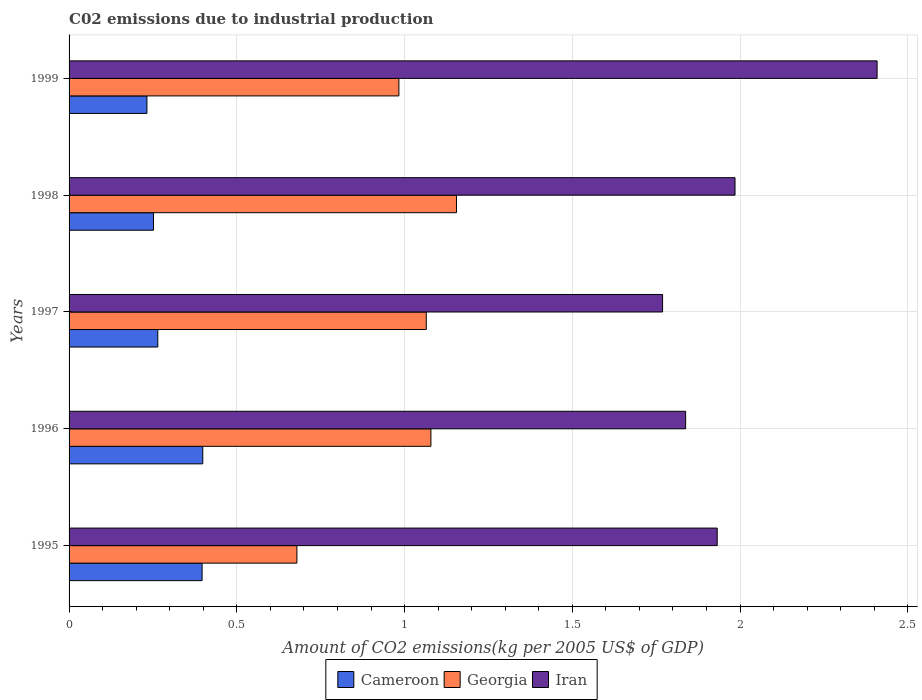How many different coloured bars are there?
Keep it short and to the point. 3. How many groups of bars are there?
Ensure brevity in your answer.  5. In how many cases, is the number of bars for a given year not equal to the number of legend labels?
Your answer should be compact. 0. What is the amount of CO2 emitted due to industrial production in Georgia in 1999?
Your answer should be very brief. 0.98. Across all years, what is the maximum amount of CO2 emitted due to industrial production in Iran?
Give a very brief answer. 2.41. Across all years, what is the minimum amount of CO2 emitted due to industrial production in Georgia?
Provide a short and direct response. 0.68. What is the total amount of CO2 emitted due to industrial production in Iran in the graph?
Your answer should be compact. 9.93. What is the difference between the amount of CO2 emitted due to industrial production in Iran in 1995 and that in 1999?
Give a very brief answer. -0.48. What is the difference between the amount of CO2 emitted due to industrial production in Cameroon in 1995 and the amount of CO2 emitted due to industrial production in Georgia in 1999?
Provide a succinct answer. -0.59. What is the average amount of CO2 emitted due to industrial production in Cameroon per year?
Your answer should be very brief. 0.31. In the year 1995, what is the difference between the amount of CO2 emitted due to industrial production in Georgia and amount of CO2 emitted due to industrial production in Iran?
Keep it short and to the point. -1.25. In how many years, is the amount of CO2 emitted due to industrial production in Georgia greater than 0.9 kg?
Keep it short and to the point. 4. What is the ratio of the amount of CO2 emitted due to industrial production in Cameroon in 1996 to that in 1999?
Provide a succinct answer. 1.72. Is the amount of CO2 emitted due to industrial production in Georgia in 1995 less than that in 1996?
Keep it short and to the point. Yes. Is the difference between the amount of CO2 emitted due to industrial production in Georgia in 1995 and 1997 greater than the difference between the amount of CO2 emitted due to industrial production in Iran in 1995 and 1997?
Your response must be concise. No. What is the difference between the highest and the second highest amount of CO2 emitted due to industrial production in Cameroon?
Provide a succinct answer. 0. What is the difference between the highest and the lowest amount of CO2 emitted due to industrial production in Iran?
Offer a very short reply. 0.64. What does the 3rd bar from the top in 1998 represents?
Provide a succinct answer. Cameroon. What does the 1st bar from the bottom in 1995 represents?
Your response must be concise. Cameroon. Is it the case that in every year, the sum of the amount of CO2 emitted due to industrial production in Georgia and amount of CO2 emitted due to industrial production in Cameroon is greater than the amount of CO2 emitted due to industrial production in Iran?
Keep it short and to the point. No. How many bars are there?
Your response must be concise. 15. How many years are there in the graph?
Provide a succinct answer. 5. Are the values on the major ticks of X-axis written in scientific E-notation?
Provide a short and direct response. No. Does the graph contain any zero values?
Make the answer very short. No. Does the graph contain grids?
Your response must be concise. Yes. Where does the legend appear in the graph?
Your answer should be very brief. Bottom center. How many legend labels are there?
Your answer should be compact. 3. What is the title of the graph?
Offer a terse response. C02 emissions due to industrial production. What is the label or title of the X-axis?
Provide a succinct answer. Amount of CO2 emissions(kg per 2005 US$ of GDP). What is the Amount of CO2 emissions(kg per 2005 US$ of GDP) of Cameroon in 1995?
Your answer should be very brief. 0.4. What is the Amount of CO2 emissions(kg per 2005 US$ of GDP) in Georgia in 1995?
Your answer should be compact. 0.68. What is the Amount of CO2 emissions(kg per 2005 US$ of GDP) in Iran in 1995?
Keep it short and to the point. 1.93. What is the Amount of CO2 emissions(kg per 2005 US$ of GDP) in Cameroon in 1996?
Ensure brevity in your answer.  0.4. What is the Amount of CO2 emissions(kg per 2005 US$ of GDP) of Georgia in 1996?
Your answer should be very brief. 1.08. What is the Amount of CO2 emissions(kg per 2005 US$ of GDP) in Iran in 1996?
Provide a short and direct response. 1.84. What is the Amount of CO2 emissions(kg per 2005 US$ of GDP) in Cameroon in 1997?
Provide a short and direct response. 0.26. What is the Amount of CO2 emissions(kg per 2005 US$ of GDP) of Georgia in 1997?
Give a very brief answer. 1.06. What is the Amount of CO2 emissions(kg per 2005 US$ of GDP) of Iran in 1997?
Provide a short and direct response. 1.77. What is the Amount of CO2 emissions(kg per 2005 US$ of GDP) in Cameroon in 1998?
Make the answer very short. 0.25. What is the Amount of CO2 emissions(kg per 2005 US$ of GDP) of Georgia in 1998?
Make the answer very short. 1.15. What is the Amount of CO2 emissions(kg per 2005 US$ of GDP) in Iran in 1998?
Give a very brief answer. 1.99. What is the Amount of CO2 emissions(kg per 2005 US$ of GDP) of Cameroon in 1999?
Offer a very short reply. 0.23. What is the Amount of CO2 emissions(kg per 2005 US$ of GDP) in Georgia in 1999?
Give a very brief answer. 0.98. What is the Amount of CO2 emissions(kg per 2005 US$ of GDP) of Iran in 1999?
Offer a terse response. 2.41. Across all years, what is the maximum Amount of CO2 emissions(kg per 2005 US$ of GDP) of Cameroon?
Ensure brevity in your answer.  0.4. Across all years, what is the maximum Amount of CO2 emissions(kg per 2005 US$ of GDP) in Georgia?
Your response must be concise. 1.15. Across all years, what is the maximum Amount of CO2 emissions(kg per 2005 US$ of GDP) in Iran?
Provide a short and direct response. 2.41. Across all years, what is the minimum Amount of CO2 emissions(kg per 2005 US$ of GDP) of Cameroon?
Your answer should be very brief. 0.23. Across all years, what is the minimum Amount of CO2 emissions(kg per 2005 US$ of GDP) of Georgia?
Provide a short and direct response. 0.68. Across all years, what is the minimum Amount of CO2 emissions(kg per 2005 US$ of GDP) of Iran?
Keep it short and to the point. 1.77. What is the total Amount of CO2 emissions(kg per 2005 US$ of GDP) of Cameroon in the graph?
Your answer should be very brief. 1.54. What is the total Amount of CO2 emissions(kg per 2005 US$ of GDP) of Georgia in the graph?
Your answer should be compact. 4.96. What is the total Amount of CO2 emissions(kg per 2005 US$ of GDP) of Iran in the graph?
Your response must be concise. 9.93. What is the difference between the Amount of CO2 emissions(kg per 2005 US$ of GDP) in Cameroon in 1995 and that in 1996?
Your response must be concise. -0. What is the difference between the Amount of CO2 emissions(kg per 2005 US$ of GDP) of Georgia in 1995 and that in 1996?
Your answer should be very brief. -0.4. What is the difference between the Amount of CO2 emissions(kg per 2005 US$ of GDP) in Iran in 1995 and that in 1996?
Ensure brevity in your answer.  0.09. What is the difference between the Amount of CO2 emissions(kg per 2005 US$ of GDP) in Cameroon in 1995 and that in 1997?
Make the answer very short. 0.13. What is the difference between the Amount of CO2 emissions(kg per 2005 US$ of GDP) in Georgia in 1995 and that in 1997?
Your answer should be compact. -0.39. What is the difference between the Amount of CO2 emissions(kg per 2005 US$ of GDP) in Iran in 1995 and that in 1997?
Offer a terse response. 0.16. What is the difference between the Amount of CO2 emissions(kg per 2005 US$ of GDP) in Cameroon in 1995 and that in 1998?
Provide a short and direct response. 0.14. What is the difference between the Amount of CO2 emissions(kg per 2005 US$ of GDP) in Georgia in 1995 and that in 1998?
Make the answer very short. -0.48. What is the difference between the Amount of CO2 emissions(kg per 2005 US$ of GDP) in Iran in 1995 and that in 1998?
Provide a short and direct response. -0.05. What is the difference between the Amount of CO2 emissions(kg per 2005 US$ of GDP) in Cameroon in 1995 and that in 1999?
Your answer should be compact. 0.16. What is the difference between the Amount of CO2 emissions(kg per 2005 US$ of GDP) in Georgia in 1995 and that in 1999?
Offer a terse response. -0.3. What is the difference between the Amount of CO2 emissions(kg per 2005 US$ of GDP) of Iran in 1995 and that in 1999?
Provide a succinct answer. -0.48. What is the difference between the Amount of CO2 emissions(kg per 2005 US$ of GDP) of Cameroon in 1996 and that in 1997?
Ensure brevity in your answer.  0.13. What is the difference between the Amount of CO2 emissions(kg per 2005 US$ of GDP) in Georgia in 1996 and that in 1997?
Your answer should be compact. 0.01. What is the difference between the Amount of CO2 emissions(kg per 2005 US$ of GDP) in Iran in 1996 and that in 1997?
Ensure brevity in your answer.  0.07. What is the difference between the Amount of CO2 emissions(kg per 2005 US$ of GDP) in Cameroon in 1996 and that in 1998?
Offer a very short reply. 0.15. What is the difference between the Amount of CO2 emissions(kg per 2005 US$ of GDP) of Georgia in 1996 and that in 1998?
Provide a succinct answer. -0.08. What is the difference between the Amount of CO2 emissions(kg per 2005 US$ of GDP) of Iran in 1996 and that in 1998?
Your answer should be compact. -0.15. What is the difference between the Amount of CO2 emissions(kg per 2005 US$ of GDP) of Cameroon in 1996 and that in 1999?
Your response must be concise. 0.17. What is the difference between the Amount of CO2 emissions(kg per 2005 US$ of GDP) of Georgia in 1996 and that in 1999?
Your answer should be compact. 0.1. What is the difference between the Amount of CO2 emissions(kg per 2005 US$ of GDP) of Iran in 1996 and that in 1999?
Your answer should be compact. -0.57. What is the difference between the Amount of CO2 emissions(kg per 2005 US$ of GDP) of Cameroon in 1997 and that in 1998?
Provide a short and direct response. 0.01. What is the difference between the Amount of CO2 emissions(kg per 2005 US$ of GDP) in Georgia in 1997 and that in 1998?
Keep it short and to the point. -0.09. What is the difference between the Amount of CO2 emissions(kg per 2005 US$ of GDP) of Iran in 1997 and that in 1998?
Keep it short and to the point. -0.22. What is the difference between the Amount of CO2 emissions(kg per 2005 US$ of GDP) in Cameroon in 1997 and that in 1999?
Offer a very short reply. 0.03. What is the difference between the Amount of CO2 emissions(kg per 2005 US$ of GDP) in Georgia in 1997 and that in 1999?
Give a very brief answer. 0.08. What is the difference between the Amount of CO2 emissions(kg per 2005 US$ of GDP) of Iran in 1997 and that in 1999?
Keep it short and to the point. -0.64. What is the difference between the Amount of CO2 emissions(kg per 2005 US$ of GDP) in Cameroon in 1998 and that in 1999?
Your response must be concise. 0.02. What is the difference between the Amount of CO2 emissions(kg per 2005 US$ of GDP) of Georgia in 1998 and that in 1999?
Your answer should be very brief. 0.17. What is the difference between the Amount of CO2 emissions(kg per 2005 US$ of GDP) of Iran in 1998 and that in 1999?
Your answer should be very brief. -0.42. What is the difference between the Amount of CO2 emissions(kg per 2005 US$ of GDP) of Cameroon in 1995 and the Amount of CO2 emissions(kg per 2005 US$ of GDP) of Georgia in 1996?
Offer a terse response. -0.68. What is the difference between the Amount of CO2 emissions(kg per 2005 US$ of GDP) of Cameroon in 1995 and the Amount of CO2 emissions(kg per 2005 US$ of GDP) of Iran in 1996?
Provide a succinct answer. -1.44. What is the difference between the Amount of CO2 emissions(kg per 2005 US$ of GDP) of Georgia in 1995 and the Amount of CO2 emissions(kg per 2005 US$ of GDP) of Iran in 1996?
Provide a short and direct response. -1.16. What is the difference between the Amount of CO2 emissions(kg per 2005 US$ of GDP) in Cameroon in 1995 and the Amount of CO2 emissions(kg per 2005 US$ of GDP) in Georgia in 1997?
Provide a succinct answer. -0.67. What is the difference between the Amount of CO2 emissions(kg per 2005 US$ of GDP) in Cameroon in 1995 and the Amount of CO2 emissions(kg per 2005 US$ of GDP) in Iran in 1997?
Ensure brevity in your answer.  -1.37. What is the difference between the Amount of CO2 emissions(kg per 2005 US$ of GDP) of Georgia in 1995 and the Amount of CO2 emissions(kg per 2005 US$ of GDP) of Iran in 1997?
Provide a succinct answer. -1.09. What is the difference between the Amount of CO2 emissions(kg per 2005 US$ of GDP) of Cameroon in 1995 and the Amount of CO2 emissions(kg per 2005 US$ of GDP) of Georgia in 1998?
Provide a short and direct response. -0.76. What is the difference between the Amount of CO2 emissions(kg per 2005 US$ of GDP) of Cameroon in 1995 and the Amount of CO2 emissions(kg per 2005 US$ of GDP) of Iran in 1998?
Keep it short and to the point. -1.59. What is the difference between the Amount of CO2 emissions(kg per 2005 US$ of GDP) in Georgia in 1995 and the Amount of CO2 emissions(kg per 2005 US$ of GDP) in Iran in 1998?
Your response must be concise. -1.31. What is the difference between the Amount of CO2 emissions(kg per 2005 US$ of GDP) in Cameroon in 1995 and the Amount of CO2 emissions(kg per 2005 US$ of GDP) in Georgia in 1999?
Give a very brief answer. -0.59. What is the difference between the Amount of CO2 emissions(kg per 2005 US$ of GDP) in Cameroon in 1995 and the Amount of CO2 emissions(kg per 2005 US$ of GDP) in Iran in 1999?
Your answer should be compact. -2.01. What is the difference between the Amount of CO2 emissions(kg per 2005 US$ of GDP) in Georgia in 1995 and the Amount of CO2 emissions(kg per 2005 US$ of GDP) in Iran in 1999?
Offer a terse response. -1.73. What is the difference between the Amount of CO2 emissions(kg per 2005 US$ of GDP) in Cameroon in 1996 and the Amount of CO2 emissions(kg per 2005 US$ of GDP) in Georgia in 1997?
Ensure brevity in your answer.  -0.67. What is the difference between the Amount of CO2 emissions(kg per 2005 US$ of GDP) in Cameroon in 1996 and the Amount of CO2 emissions(kg per 2005 US$ of GDP) in Iran in 1997?
Make the answer very short. -1.37. What is the difference between the Amount of CO2 emissions(kg per 2005 US$ of GDP) of Georgia in 1996 and the Amount of CO2 emissions(kg per 2005 US$ of GDP) of Iran in 1997?
Your response must be concise. -0.69. What is the difference between the Amount of CO2 emissions(kg per 2005 US$ of GDP) of Cameroon in 1996 and the Amount of CO2 emissions(kg per 2005 US$ of GDP) of Georgia in 1998?
Keep it short and to the point. -0.76. What is the difference between the Amount of CO2 emissions(kg per 2005 US$ of GDP) in Cameroon in 1996 and the Amount of CO2 emissions(kg per 2005 US$ of GDP) in Iran in 1998?
Offer a very short reply. -1.59. What is the difference between the Amount of CO2 emissions(kg per 2005 US$ of GDP) of Georgia in 1996 and the Amount of CO2 emissions(kg per 2005 US$ of GDP) of Iran in 1998?
Provide a succinct answer. -0.91. What is the difference between the Amount of CO2 emissions(kg per 2005 US$ of GDP) in Cameroon in 1996 and the Amount of CO2 emissions(kg per 2005 US$ of GDP) in Georgia in 1999?
Provide a short and direct response. -0.58. What is the difference between the Amount of CO2 emissions(kg per 2005 US$ of GDP) in Cameroon in 1996 and the Amount of CO2 emissions(kg per 2005 US$ of GDP) in Iran in 1999?
Provide a short and direct response. -2.01. What is the difference between the Amount of CO2 emissions(kg per 2005 US$ of GDP) in Georgia in 1996 and the Amount of CO2 emissions(kg per 2005 US$ of GDP) in Iran in 1999?
Ensure brevity in your answer.  -1.33. What is the difference between the Amount of CO2 emissions(kg per 2005 US$ of GDP) of Cameroon in 1997 and the Amount of CO2 emissions(kg per 2005 US$ of GDP) of Georgia in 1998?
Your answer should be very brief. -0.89. What is the difference between the Amount of CO2 emissions(kg per 2005 US$ of GDP) of Cameroon in 1997 and the Amount of CO2 emissions(kg per 2005 US$ of GDP) of Iran in 1998?
Offer a terse response. -1.72. What is the difference between the Amount of CO2 emissions(kg per 2005 US$ of GDP) of Georgia in 1997 and the Amount of CO2 emissions(kg per 2005 US$ of GDP) of Iran in 1998?
Your answer should be very brief. -0.92. What is the difference between the Amount of CO2 emissions(kg per 2005 US$ of GDP) in Cameroon in 1997 and the Amount of CO2 emissions(kg per 2005 US$ of GDP) in Georgia in 1999?
Give a very brief answer. -0.72. What is the difference between the Amount of CO2 emissions(kg per 2005 US$ of GDP) in Cameroon in 1997 and the Amount of CO2 emissions(kg per 2005 US$ of GDP) in Iran in 1999?
Make the answer very short. -2.14. What is the difference between the Amount of CO2 emissions(kg per 2005 US$ of GDP) of Georgia in 1997 and the Amount of CO2 emissions(kg per 2005 US$ of GDP) of Iran in 1999?
Your response must be concise. -1.34. What is the difference between the Amount of CO2 emissions(kg per 2005 US$ of GDP) in Cameroon in 1998 and the Amount of CO2 emissions(kg per 2005 US$ of GDP) in Georgia in 1999?
Provide a succinct answer. -0.73. What is the difference between the Amount of CO2 emissions(kg per 2005 US$ of GDP) of Cameroon in 1998 and the Amount of CO2 emissions(kg per 2005 US$ of GDP) of Iran in 1999?
Keep it short and to the point. -2.16. What is the difference between the Amount of CO2 emissions(kg per 2005 US$ of GDP) in Georgia in 1998 and the Amount of CO2 emissions(kg per 2005 US$ of GDP) in Iran in 1999?
Your answer should be very brief. -1.25. What is the average Amount of CO2 emissions(kg per 2005 US$ of GDP) in Cameroon per year?
Offer a very short reply. 0.31. What is the average Amount of CO2 emissions(kg per 2005 US$ of GDP) in Georgia per year?
Your answer should be compact. 0.99. What is the average Amount of CO2 emissions(kg per 2005 US$ of GDP) in Iran per year?
Give a very brief answer. 1.99. In the year 1995, what is the difference between the Amount of CO2 emissions(kg per 2005 US$ of GDP) of Cameroon and Amount of CO2 emissions(kg per 2005 US$ of GDP) of Georgia?
Offer a very short reply. -0.28. In the year 1995, what is the difference between the Amount of CO2 emissions(kg per 2005 US$ of GDP) of Cameroon and Amount of CO2 emissions(kg per 2005 US$ of GDP) of Iran?
Make the answer very short. -1.54. In the year 1995, what is the difference between the Amount of CO2 emissions(kg per 2005 US$ of GDP) in Georgia and Amount of CO2 emissions(kg per 2005 US$ of GDP) in Iran?
Your answer should be very brief. -1.25. In the year 1996, what is the difference between the Amount of CO2 emissions(kg per 2005 US$ of GDP) in Cameroon and Amount of CO2 emissions(kg per 2005 US$ of GDP) in Georgia?
Provide a succinct answer. -0.68. In the year 1996, what is the difference between the Amount of CO2 emissions(kg per 2005 US$ of GDP) in Cameroon and Amount of CO2 emissions(kg per 2005 US$ of GDP) in Iran?
Offer a terse response. -1.44. In the year 1996, what is the difference between the Amount of CO2 emissions(kg per 2005 US$ of GDP) in Georgia and Amount of CO2 emissions(kg per 2005 US$ of GDP) in Iran?
Your answer should be compact. -0.76. In the year 1997, what is the difference between the Amount of CO2 emissions(kg per 2005 US$ of GDP) of Cameroon and Amount of CO2 emissions(kg per 2005 US$ of GDP) of Georgia?
Your answer should be very brief. -0.8. In the year 1997, what is the difference between the Amount of CO2 emissions(kg per 2005 US$ of GDP) of Cameroon and Amount of CO2 emissions(kg per 2005 US$ of GDP) of Iran?
Provide a short and direct response. -1.5. In the year 1997, what is the difference between the Amount of CO2 emissions(kg per 2005 US$ of GDP) in Georgia and Amount of CO2 emissions(kg per 2005 US$ of GDP) in Iran?
Keep it short and to the point. -0.7. In the year 1998, what is the difference between the Amount of CO2 emissions(kg per 2005 US$ of GDP) in Cameroon and Amount of CO2 emissions(kg per 2005 US$ of GDP) in Georgia?
Your response must be concise. -0.9. In the year 1998, what is the difference between the Amount of CO2 emissions(kg per 2005 US$ of GDP) in Cameroon and Amount of CO2 emissions(kg per 2005 US$ of GDP) in Iran?
Give a very brief answer. -1.73. In the year 1998, what is the difference between the Amount of CO2 emissions(kg per 2005 US$ of GDP) of Georgia and Amount of CO2 emissions(kg per 2005 US$ of GDP) of Iran?
Ensure brevity in your answer.  -0.83. In the year 1999, what is the difference between the Amount of CO2 emissions(kg per 2005 US$ of GDP) in Cameroon and Amount of CO2 emissions(kg per 2005 US$ of GDP) in Georgia?
Provide a short and direct response. -0.75. In the year 1999, what is the difference between the Amount of CO2 emissions(kg per 2005 US$ of GDP) in Cameroon and Amount of CO2 emissions(kg per 2005 US$ of GDP) in Iran?
Ensure brevity in your answer.  -2.18. In the year 1999, what is the difference between the Amount of CO2 emissions(kg per 2005 US$ of GDP) of Georgia and Amount of CO2 emissions(kg per 2005 US$ of GDP) of Iran?
Offer a very short reply. -1.43. What is the ratio of the Amount of CO2 emissions(kg per 2005 US$ of GDP) in Georgia in 1995 to that in 1996?
Provide a short and direct response. 0.63. What is the ratio of the Amount of CO2 emissions(kg per 2005 US$ of GDP) in Iran in 1995 to that in 1996?
Ensure brevity in your answer.  1.05. What is the ratio of the Amount of CO2 emissions(kg per 2005 US$ of GDP) of Cameroon in 1995 to that in 1997?
Your answer should be very brief. 1.5. What is the ratio of the Amount of CO2 emissions(kg per 2005 US$ of GDP) in Georgia in 1995 to that in 1997?
Provide a succinct answer. 0.64. What is the ratio of the Amount of CO2 emissions(kg per 2005 US$ of GDP) of Iran in 1995 to that in 1997?
Ensure brevity in your answer.  1.09. What is the ratio of the Amount of CO2 emissions(kg per 2005 US$ of GDP) of Cameroon in 1995 to that in 1998?
Keep it short and to the point. 1.58. What is the ratio of the Amount of CO2 emissions(kg per 2005 US$ of GDP) of Georgia in 1995 to that in 1998?
Make the answer very short. 0.59. What is the ratio of the Amount of CO2 emissions(kg per 2005 US$ of GDP) of Iran in 1995 to that in 1998?
Keep it short and to the point. 0.97. What is the ratio of the Amount of CO2 emissions(kg per 2005 US$ of GDP) in Cameroon in 1995 to that in 1999?
Your answer should be compact. 1.71. What is the ratio of the Amount of CO2 emissions(kg per 2005 US$ of GDP) of Georgia in 1995 to that in 1999?
Provide a short and direct response. 0.69. What is the ratio of the Amount of CO2 emissions(kg per 2005 US$ of GDP) in Iran in 1995 to that in 1999?
Offer a terse response. 0.8. What is the ratio of the Amount of CO2 emissions(kg per 2005 US$ of GDP) in Cameroon in 1996 to that in 1997?
Provide a short and direct response. 1.51. What is the ratio of the Amount of CO2 emissions(kg per 2005 US$ of GDP) of Georgia in 1996 to that in 1997?
Your response must be concise. 1.01. What is the ratio of the Amount of CO2 emissions(kg per 2005 US$ of GDP) in Iran in 1996 to that in 1997?
Provide a succinct answer. 1.04. What is the ratio of the Amount of CO2 emissions(kg per 2005 US$ of GDP) in Cameroon in 1996 to that in 1998?
Give a very brief answer. 1.58. What is the ratio of the Amount of CO2 emissions(kg per 2005 US$ of GDP) in Georgia in 1996 to that in 1998?
Your answer should be very brief. 0.93. What is the ratio of the Amount of CO2 emissions(kg per 2005 US$ of GDP) of Iran in 1996 to that in 1998?
Ensure brevity in your answer.  0.93. What is the ratio of the Amount of CO2 emissions(kg per 2005 US$ of GDP) of Cameroon in 1996 to that in 1999?
Your response must be concise. 1.72. What is the ratio of the Amount of CO2 emissions(kg per 2005 US$ of GDP) of Georgia in 1996 to that in 1999?
Make the answer very short. 1.1. What is the ratio of the Amount of CO2 emissions(kg per 2005 US$ of GDP) of Iran in 1996 to that in 1999?
Give a very brief answer. 0.76. What is the ratio of the Amount of CO2 emissions(kg per 2005 US$ of GDP) of Cameroon in 1997 to that in 1998?
Your answer should be very brief. 1.05. What is the ratio of the Amount of CO2 emissions(kg per 2005 US$ of GDP) in Georgia in 1997 to that in 1998?
Your answer should be compact. 0.92. What is the ratio of the Amount of CO2 emissions(kg per 2005 US$ of GDP) in Iran in 1997 to that in 1998?
Offer a very short reply. 0.89. What is the ratio of the Amount of CO2 emissions(kg per 2005 US$ of GDP) in Cameroon in 1997 to that in 1999?
Make the answer very short. 1.14. What is the ratio of the Amount of CO2 emissions(kg per 2005 US$ of GDP) of Georgia in 1997 to that in 1999?
Offer a very short reply. 1.08. What is the ratio of the Amount of CO2 emissions(kg per 2005 US$ of GDP) in Iran in 1997 to that in 1999?
Your answer should be very brief. 0.73. What is the ratio of the Amount of CO2 emissions(kg per 2005 US$ of GDP) of Cameroon in 1998 to that in 1999?
Your answer should be compact. 1.08. What is the ratio of the Amount of CO2 emissions(kg per 2005 US$ of GDP) in Georgia in 1998 to that in 1999?
Offer a very short reply. 1.17. What is the ratio of the Amount of CO2 emissions(kg per 2005 US$ of GDP) of Iran in 1998 to that in 1999?
Give a very brief answer. 0.82. What is the difference between the highest and the second highest Amount of CO2 emissions(kg per 2005 US$ of GDP) in Cameroon?
Provide a short and direct response. 0. What is the difference between the highest and the second highest Amount of CO2 emissions(kg per 2005 US$ of GDP) of Georgia?
Your answer should be compact. 0.08. What is the difference between the highest and the second highest Amount of CO2 emissions(kg per 2005 US$ of GDP) of Iran?
Your answer should be compact. 0.42. What is the difference between the highest and the lowest Amount of CO2 emissions(kg per 2005 US$ of GDP) of Cameroon?
Give a very brief answer. 0.17. What is the difference between the highest and the lowest Amount of CO2 emissions(kg per 2005 US$ of GDP) of Georgia?
Your answer should be very brief. 0.48. What is the difference between the highest and the lowest Amount of CO2 emissions(kg per 2005 US$ of GDP) in Iran?
Provide a succinct answer. 0.64. 